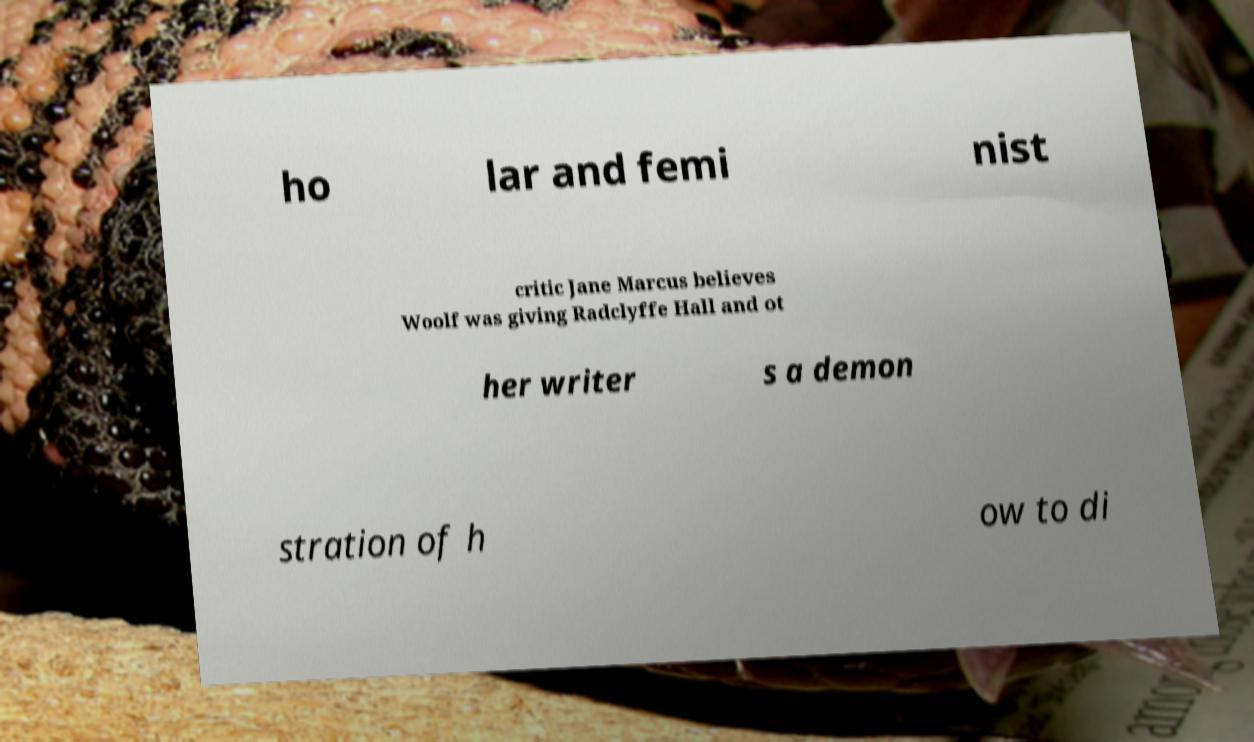I need the written content from this picture converted into text. Can you do that? ho lar and femi nist critic Jane Marcus believes Woolf was giving Radclyffe Hall and ot her writer s a demon stration of h ow to di 